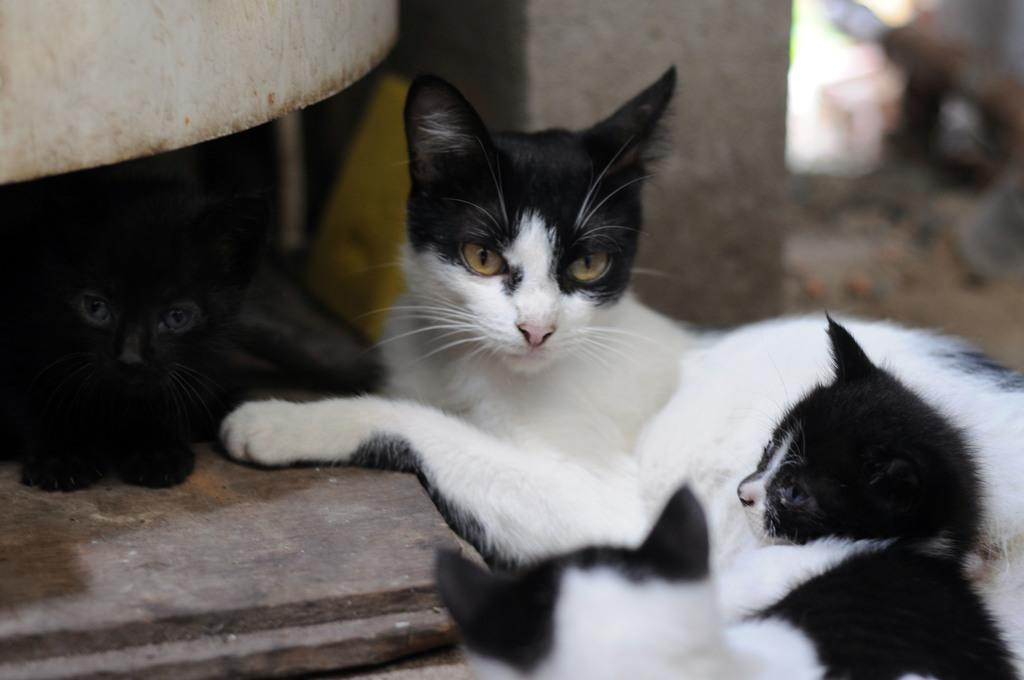What type of animals are in the image? There are cats in the image. What can be seen in the background of the image? There is a pillar in the background of the image. What type of flooring is visible on the left side of the image? There is wooden flooring on the left side of the image. How many sheep can be seen in the image? There are no sheep present in the image. Is there a horse visible in the image? No, there is no horse present in the image. 